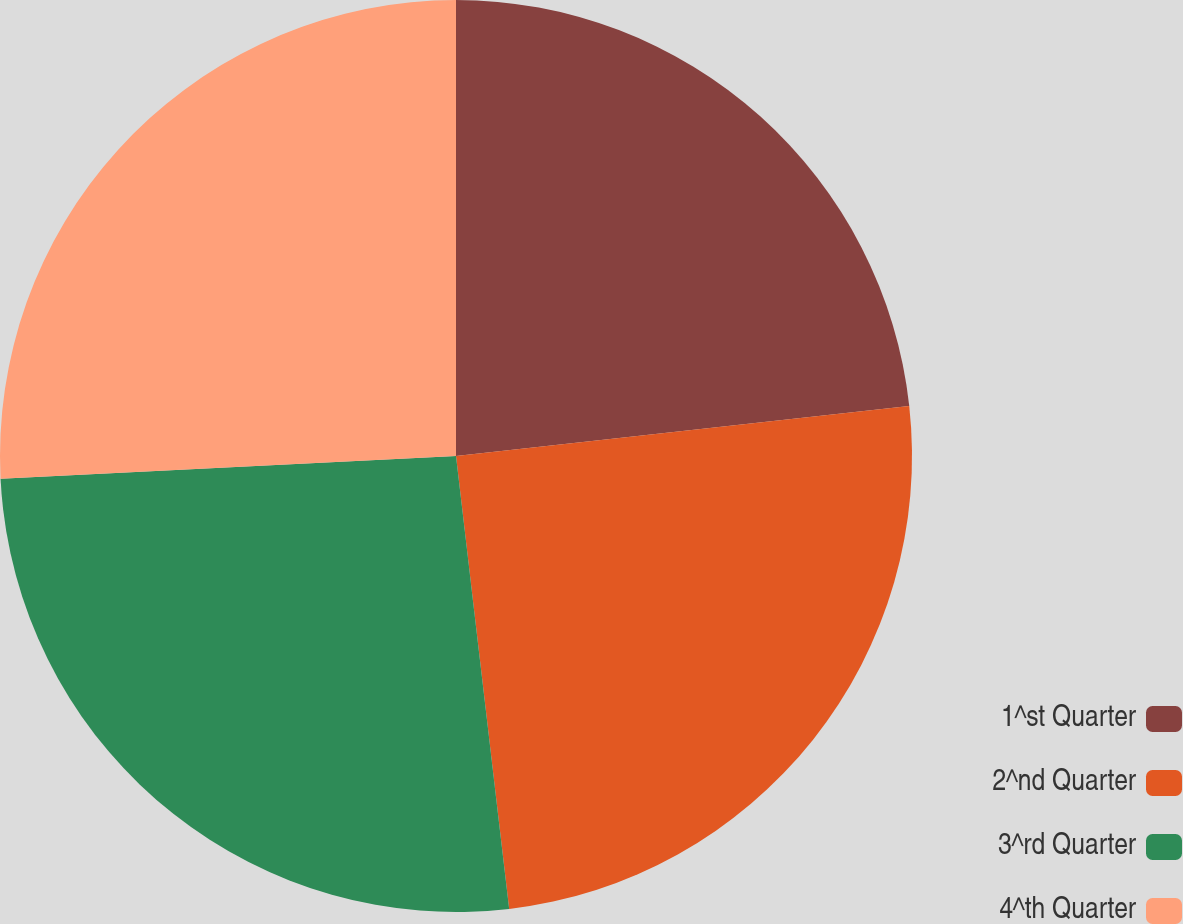Convert chart to OTSL. <chart><loc_0><loc_0><loc_500><loc_500><pie_chart><fcel>1^st Quarter<fcel>2^nd Quarter<fcel>3^rd Quarter<fcel>4^th Quarter<nl><fcel>23.25%<fcel>24.89%<fcel>26.07%<fcel>25.79%<nl></chart> 